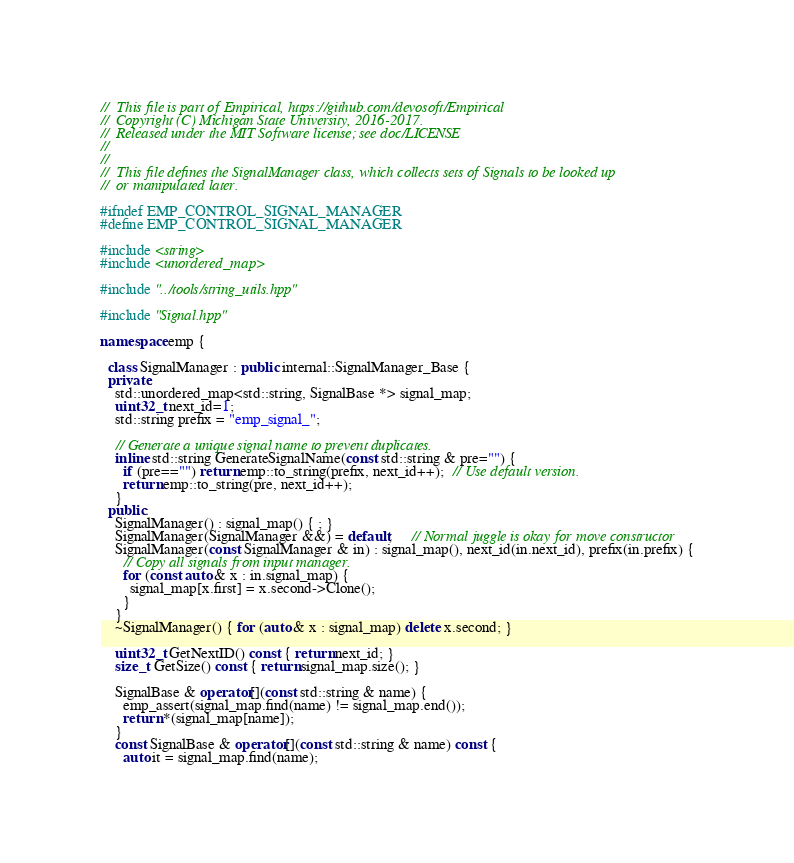<code> <loc_0><loc_0><loc_500><loc_500><_C++_>//  This file is part of Empirical, https://github.com/devosoft/Empirical
//  Copyright (C) Michigan State University, 2016-2017.
//  Released under the MIT Software license; see doc/LICENSE
//
//
//  This file defines the SignalManager class, which collects sets of Signals to be looked up
//  or manipulated later.

#ifndef EMP_CONTROL_SIGNAL_MANAGER
#define EMP_CONTROL_SIGNAL_MANAGER

#include <string>
#include <unordered_map>

#include "../tools/string_utils.hpp"

#include "Signal.hpp"

namespace emp {

  class SignalManager : public internal::SignalManager_Base {
  private:
    std::unordered_map<std::string, SignalBase *> signal_map;
    uint32_t next_id=1;
    std::string prefix = "emp_signal_";

    // Generate a unique signal name to prevent duplicates.
    inline std::string GenerateSignalName(const std::string & pre="") {
      if (pre=="") return emp::to_string(prefix, next_id++);  // Use default version.
      return emp::to_string(pre, next_id++);
    }
  public:
    SignalManager() : signal_map() { ; }
    SignalManager(SignalManager &&) = default;     // Normal juggle is okay for move constructor
    SignalManager(const SignalManager & in) : signal_map(), next_id(in.next_id), prefix(in.prefix) {
      // Copy all signals from input manager.
      for (const auto & x : in.signal_map) {
        signal_map[x.first] = x.second->Clone();
      }
    }
    ~SignalManager() { for (auto & x : signal_map) delete x.second; }

    uint32_t GetNextID() const { return next_id; }
    size_t GetSize() const { return signal_map.size(); }

    SignalBase & operator[](const std::string & name) {
      emp_assert(signal_map.find(name) != signal_map.end());
      return *(signal_map[name]);
    }
    const SignalBase & operator[](const std::string & name) const {
      auto it = signal_map.find(name);</code> 